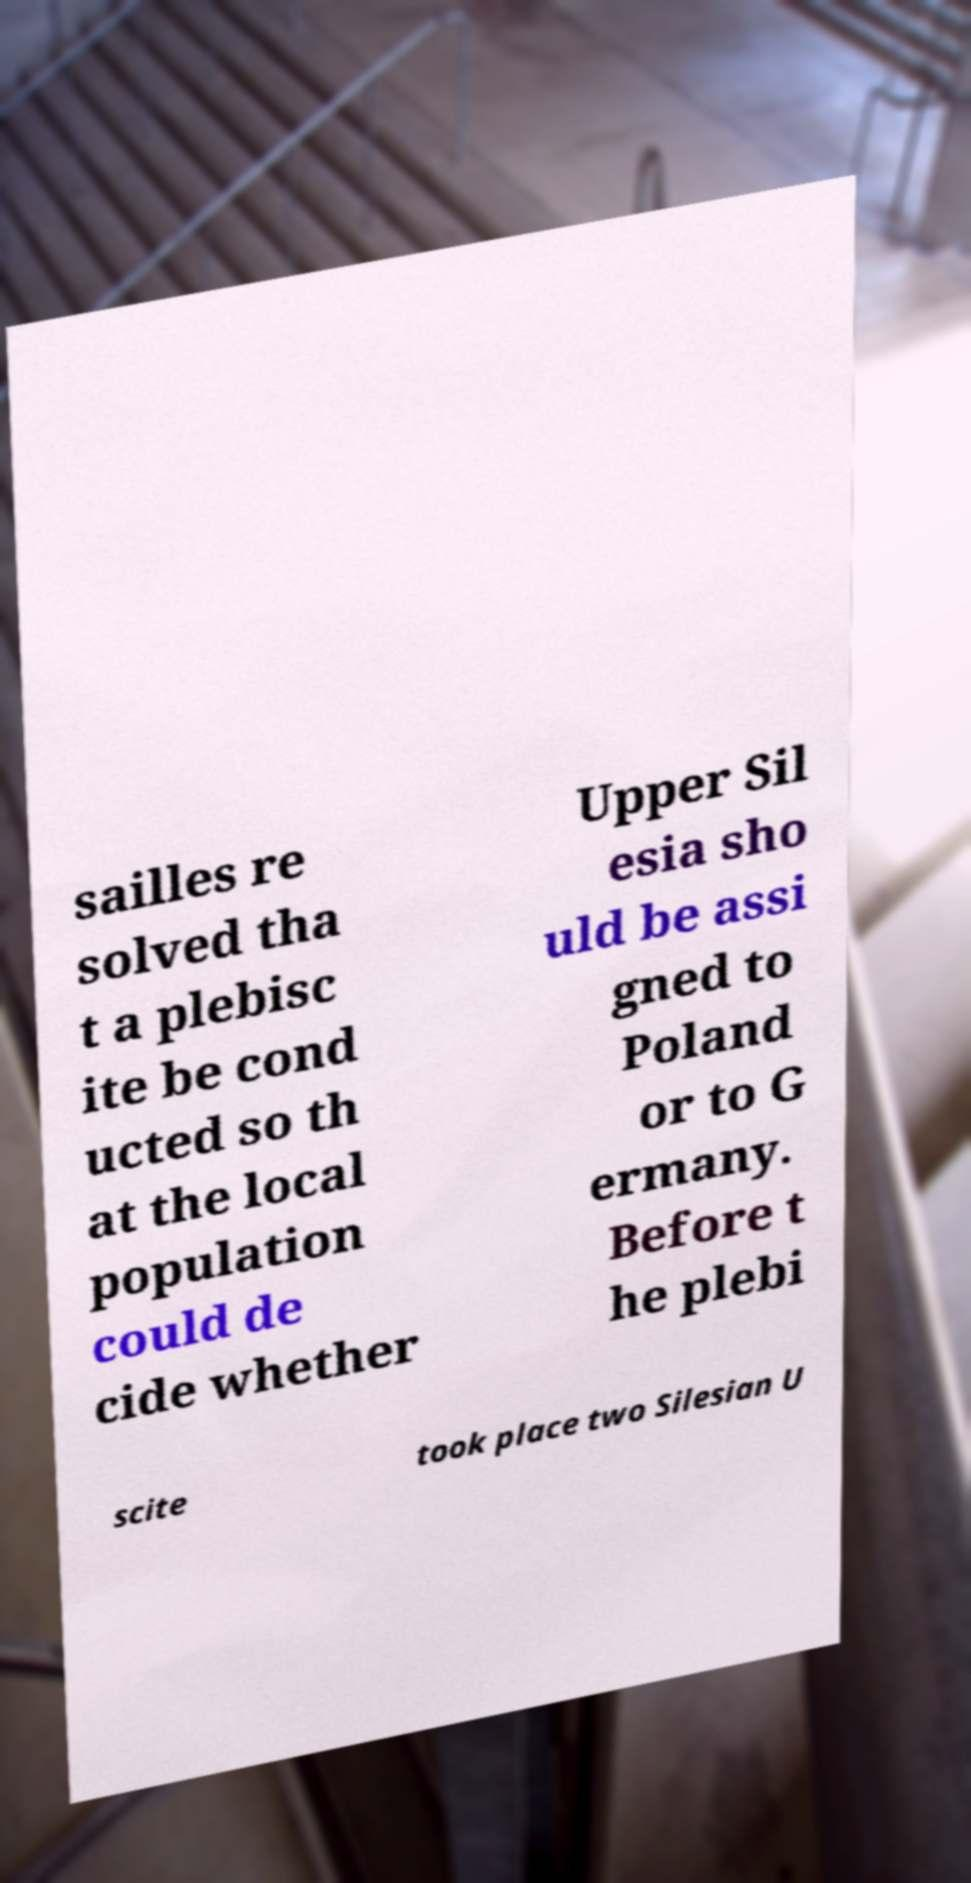Please identify and transcribe the text found in this image. sailles re solved tha t a plebisc ite be cond ucted so th at the local population could de cide whether Upper Sil esia sho uld be assi gned to Poland or to G ermany. Before t he plebi scite took place two Silesian U 